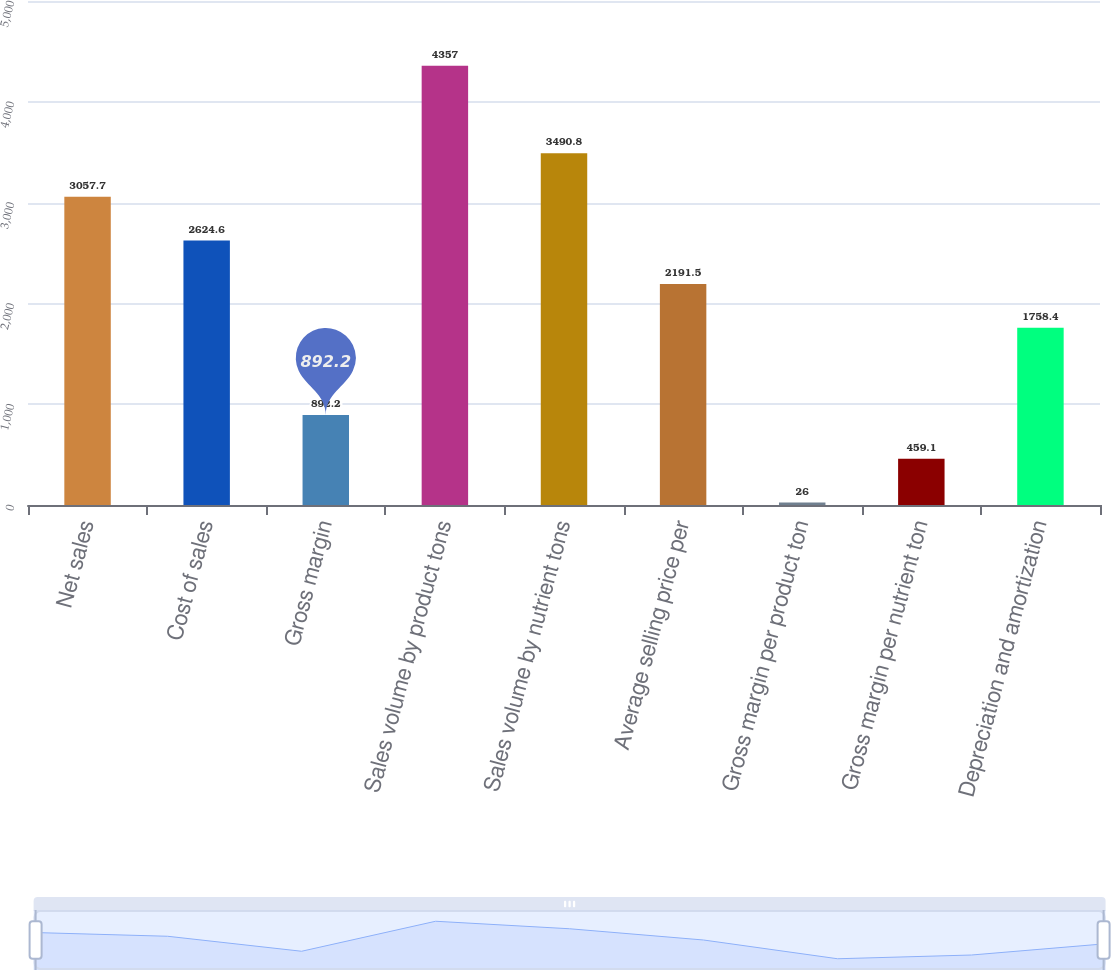Convert chart. <chart><loc_0><loc_0><loc_500><loc_500><bar_chart><fcel>Net sales<fcel>Cost of sales<fcel>Gross margin<fcel>Sales volume by product tons<fcel>Sales volume by nutrient tons<fcel>Average selling price per<fcel>Gross margin per product ton<fcel>Gross margin per nutrient ton<fcel>Depreciation and amortization<nl><fcel>3057.7<fcel>2624.6<fcel>892.2<fcel>4357<fcel>3490.8<fcel>2191.5<fcel>26<fcel>459.1<fcel>1758.4<nl></chart> 